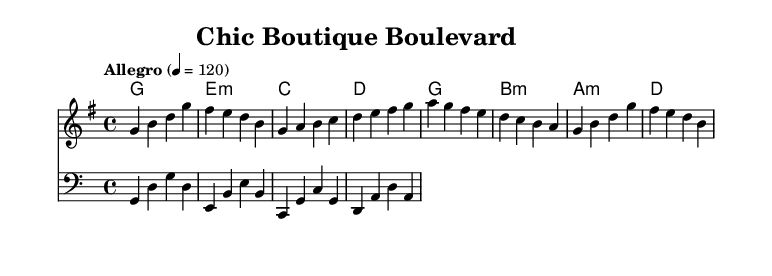What is the key signature of this music? The key signature of this piece is G major, indicated by the one sharp (F#) in the key signature at the beginning of the staff.
Answer: G major What is the time signature of this music? The time signature is 4/4, shown at the beginning of the sheet music, indicating that there are four beats in each measure and the quarter note gets one beat.
Answer: 4/4 What is the tempo marking of this composition? The tempo marking indicates the piece should be played "Allegro" at a speed of 120 beats per minute, which is written at the start of the piece.
Answer: Allegro, 120 How many measures are in the melody? By counting the individual measures separated by vertical lines in the melody staff, there are a total of eight measures present in the melody.
Answer: 8 What chord follows the 'E minor' chord in the chord progression? In the chord progression, the chord that follows E minor is C major. This can be verified by looking at the order of chords written sequentially in the chord staff.
Answer: C major Which clef is used for the bass line? The bass line is written using the bass clef, signified by the bass clef symbol at the beginning of the bass staff.
Answer: Bass clef What is the last note in the melody? The last note in the melody is an 'A', which is indicated by the final pitch in the melodic staff before the end of the score.
Answer: A 